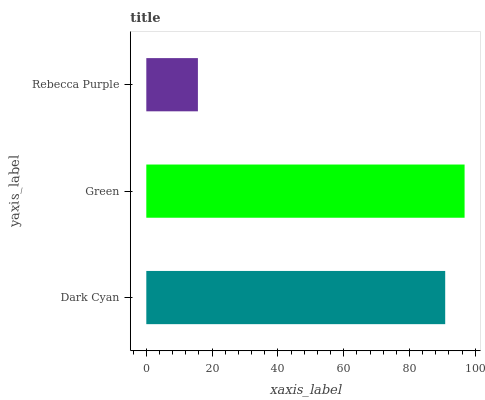Is Rebecca Purple the minimum?
Answer yes or no. Yes. Is Green the maximum?
Answer yes or no. Yes. Is Green the minimum?
Answer yes or no. No. Is Rebecca Purple the maximum?
Answer yes or no. No. Is Green greater than Rebecca Purple?
Answer yes or no. Yes. Is Rebecca Purple less than Green?
Answer yes or no. Yes. Is Rebecca Purple greater than Green?
Answer yes or no. No. Is Green less than Rebecca Purple?
Answer yes or no. No. Is Dark Cyan the high median?
Answer yes or no. Yes. Is Dark Cyan the low median?
Answer yes or no. Yes. Is Rebecca Purple the high median?
Answer yes or no. No. Is Rebecca Purple the low median?
Answer yes or no. No. 